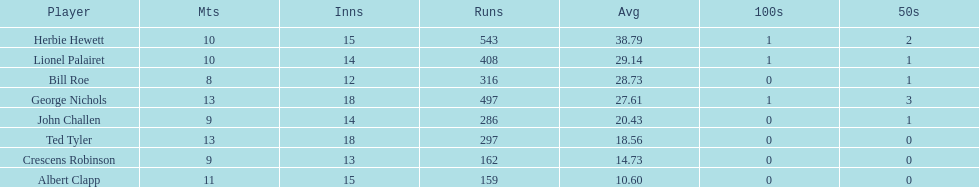What was the total number of runs ted tyler had? 297. 